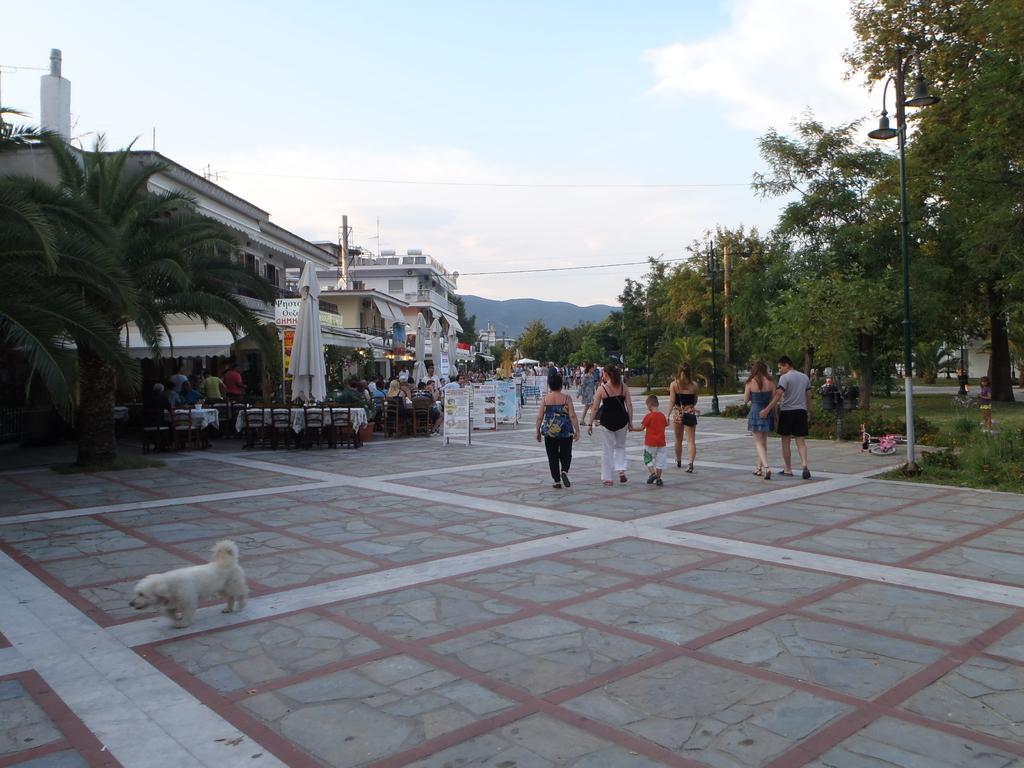Can you describe this image briefly? As we can see in the image there are few people here and there, trees, buildings, banners, dog, chairs, tables and sky. 